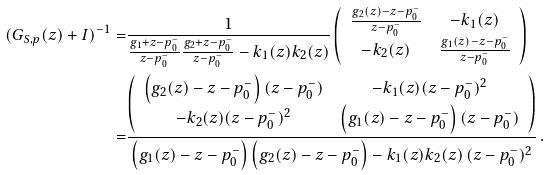Convert formula to latex. <formula><loc_0><loc_0><loc_500><loc_500>( G _ { S , p } ( z ) + I ) ^ { - 1 } = & \frac { 1 } { \frac { g _ { 1 } + z - p _ { 0 } ^ { - } } { z - p _ { 0 } ^ { - } } \frac { g _ { 2 } + z - p _ { 0 } ^ { - } } { z - p _ { 0 } ^ { - } } - k _ { 1 } ( z ) k _ { 2 } ( z ) } \left ( \begin{array} { c c } \frac { g _ { 2 } ( z ) - z - p _ { 0 } ^ { - } } { z - p _ { 0 } ^ { - } } & - k _ { 1 } ( z ) \\ - k _ { 2 } ( z ) & \frac { g _ { 1 } ( z ) - z - p _ { 0 } ^ { - } } { z - p _ { 0 } ^ { - } } \end{array} \right ) \\ = & \frac { \left ( \begin{array} { c c } \left ( g _ { 2 } ( z ) - z - p _ { 0 } ^ { - } \right ) ( z - p _ { 0 } ^ { - } ) & - k _ { 1 } ( z ) ( z - p _ { 0 } ^ { - } ) ^ { 2 } \\ - k _ { 2 } ( z ) ( z - p _ { 0 } ^ { - } ) ^ { 2 } & \left ( g _ { 1 } ( z ) - z - p _ { 0 } ^ { - } \right ) ( z - p _ { 0 } ^ { - } ) \end{array} \right ) } { \left ( g _ { 1 } ( z ) - z - p _ { 0 } ^ { - } \right ) \left ( g _ { 2 } ( z ) - z - p _ { 0 } ^ { - } \right ) - k _ { 1 } ( z ) k _ { 2 } ( z ) \, ( z - p _ { 0 } ^ { - } ) ^ { 2 } } \, .</formula> 